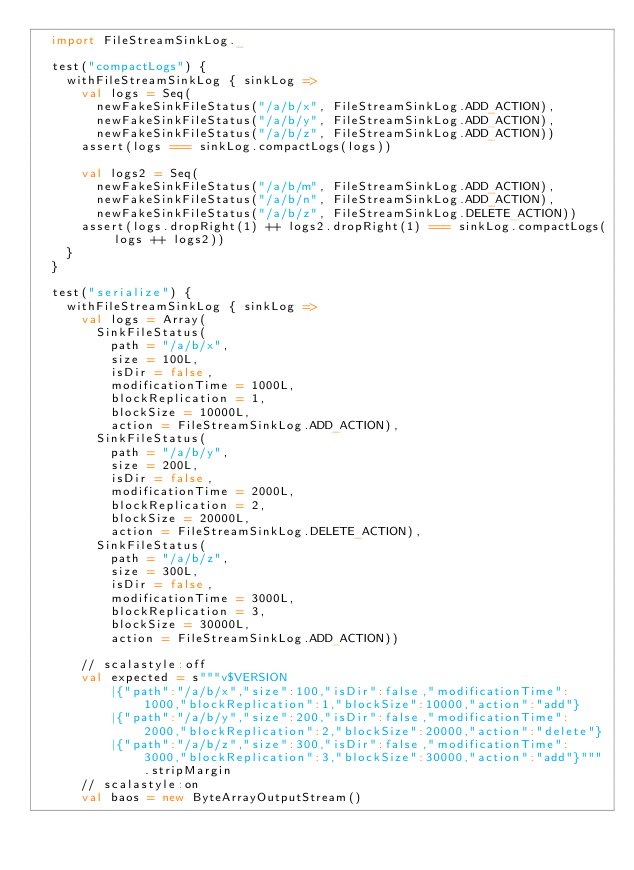<code> <loc_0><loc_0><loc_500><loc_500><_Scala_>  import FileStreamSinkLog._

  test("compactLogs") {
    withFileStreamSinkLog { sinkLog =>
      val logs = Seq(
        newFakeSinkFileStatus("/a/b/x", FileStreamSinkLog.ADD_ACTION),
        newFakeSinkFileStatus("/a/b/y", FileStreamSinkLog.ADD_ACTION),
        newFakeSinkFileStatus("/a/b/z", FileStreamSinkLog.ADD_ACTION))
      assert(logs === sinkLog.compactLogs(logs))

      val logs2 = Seq(
        newFakeSinkFileStatus("/a/b/m", FileStreamSinkLog.ADD_ACTION),
        newFakeSinkFileStatus("/a/b/n", FileStreamSinkLog.ADD_ACTION),
        newFakeSinkFileStatus("/a/b/z", FileStreamSinkLog.DELETE_ACTION))
      assert(logs.dropRight(1) ++ logs2.dropRight(1) === sinkLog.compactLogs(logs ++ logs2))
    }
  }

  test("serialize") {
    withFileStreamSinkLog { sinkLog =>
      val logs = Array(
        SinkFileStatus(
          path = "/a/b/x",
          size = 100L,
          isDir = false,
          modificationTime = 1000L,
          blockReplication = 1,
          blockSize = 10000L,
          action = FileStreamSinkLog.ADD_ACTION),
        SinkFileStatus(
          path = "/a/b/y",
          size = 200L,
          isDir = false,
          modificationTime = 2000L,
          blockReplication = 2,
          blockSize = 20000L,
          action = FileStreamSinkLog.DELETE_ACTION),
        SinkFileStatus(
          path = "/a/b/z",
          size = 300L,
          isDir = false,
          modificationTime = 3000L,
          blockReplication = 3,
          blockSize = 30000L,
          action = FileStreamSinkLog.ADD_ACTION))

      // scalastyle:off
      val expected = s"""v$VERSION
          |{"path":"/a/b/x","size":100,"isDir":false,"modificationTime":1000,"blockReplication":1,"blockSize":10000,"action":"add"}
          |{"path":"/a/b/y","size":200,"isDir":false,"modificationTime":2000,"blockReplication":2,"blockSize":20000,"action":"delete"}
          |{"path":"/a/b/z","size":300,"isDir":false,"modificationTime":3000,"blockReplication":3,"blockSize":30000,"action":"add"}""".stripMargin
      // scalastyle:on
      val baos = new ByteArrayOutputStream()</code> 